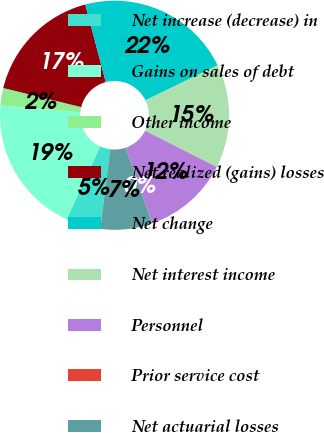Convert chart to OTSL. <chart><loc_0><loc_0><loc_500><loc_500><pie_chart><fcel>Net increase (decrease) in<fcel>Gains on sales of debt<fcel>Other income<fcel>Net realized (gains) losses<fcel>Net change<fcel>Net interest income<fcel>Personnel<fcel>Prior service cost<fcel>Net actuarial losses<nl><fcel>4.89%<fcel>19.5%<fcel>2.45%<fcel>17.07%<fcel>21.94%<fcel>14.63%<fcel>12.19%<fcel>0.02%<fcel>7.32%<nl></chart> 